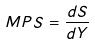<formula> <loc_0><loc_0><loc_500><loc_500>M P S = \frac { d S } { d Y }</formula> 